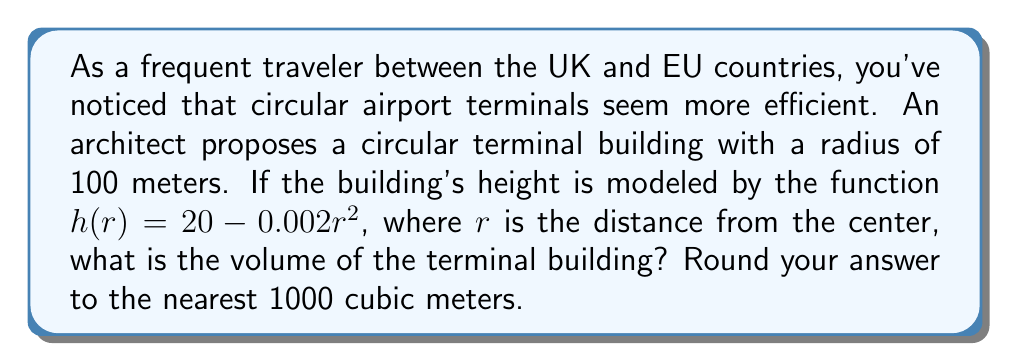Can you answer this question? Let's approach this step-by-step using principles of differential geometry:

1) The terminal building is a solid of revolution, formed by rotating the function $h(r)$ around the vertical axis.

2) The volume of a solid of revolution is given by the formula:

   $$V = 2\pi \int_0^R r h(r) dr$$

   where $R$ is the radius of the base.

3) We're given:
   - $R = 100$ meters
   - $h(r) = 20 - 0.002r^2$

4) Let's substitute these into our volume formula:

   $$V = 2\pi \int_0^{100} r (20 - 0.002r^2) dr$$

5) Expanding the integrand:

   $$V = 2\pi \int_0^{100} (20r - 0.002r^3) dr$$

6) Integrating:

   $$V = 2\pi \left[ 10r^2 - 0.0005r^4 \right]_0^{100}$$

7) Evaluating the definite integral:

   $$V = 2\pi \left[ (10 \cdot 100^2 - 0.0005 \cdot 100^4) - (10 \cdot 0^2 - 0.0005 \cdot 0^4) \right]$$
   $$V = 2\pi \left[ 100,000 - 50,000 \right]$$
   $$V = 2\pi \cdot 50,000$$

8) Calculating:

   $$V = 314,159.27... \text{ cubic meters}$$

9) Rounding to the nearest 1000 cubic meters:

   $$V \approx 314,000 \text{ cubic meters}$$
Answer: 314,000 cubic meters 